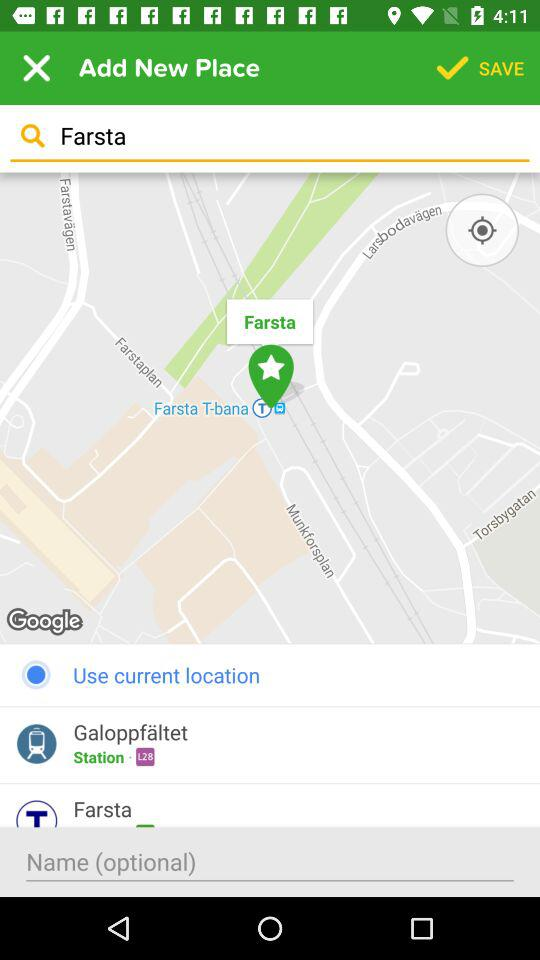Which city is selected?
When the provided information is insufficient, respond with <no answer>. <no answer> 